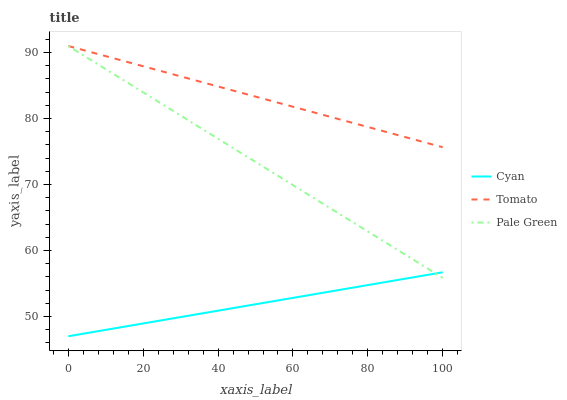Does Cyan have the minimum area under the curve?
Answer yes or no. Yes. Does Tomato have the maximum area under the curve?
Answer yes or no. Yes. Does Pale Green have the minimum area under the curve?
Answer yes or no. No. Does Pale Green have the maximum area under the curve?
Answer yes or no. No. Is Cyan the smoothest?
Answer yes or no. Yes. Is Tomato the roughest?
Answer yes or no. Yes. Is Pale Green the smoothest?
Answer yes or no. No. Is Pale Green the roughest?
Answer yes or no. No. Does Pale Green have the lowest value?
Answer yes or no. No. Does Pale Green have the highest value?
Answer yes or no. Yes. Does Cyan have the highest value?
Answer yes or no. No. Is Cyan less than Tomato?
Answer yes or no. Yes. Is Tomato greater than Cyan?
Answer yes or no. Yes. Does Pale Green intersect Cyan?
Answer yes or no. Yes. Is Pale Green less than Cyan?
Answer yes or no. No. Is Pale Green greater than Cyan?
Answer yes or no. No. Does Cyan intersect Tomato?
Answer yes or no. No. 